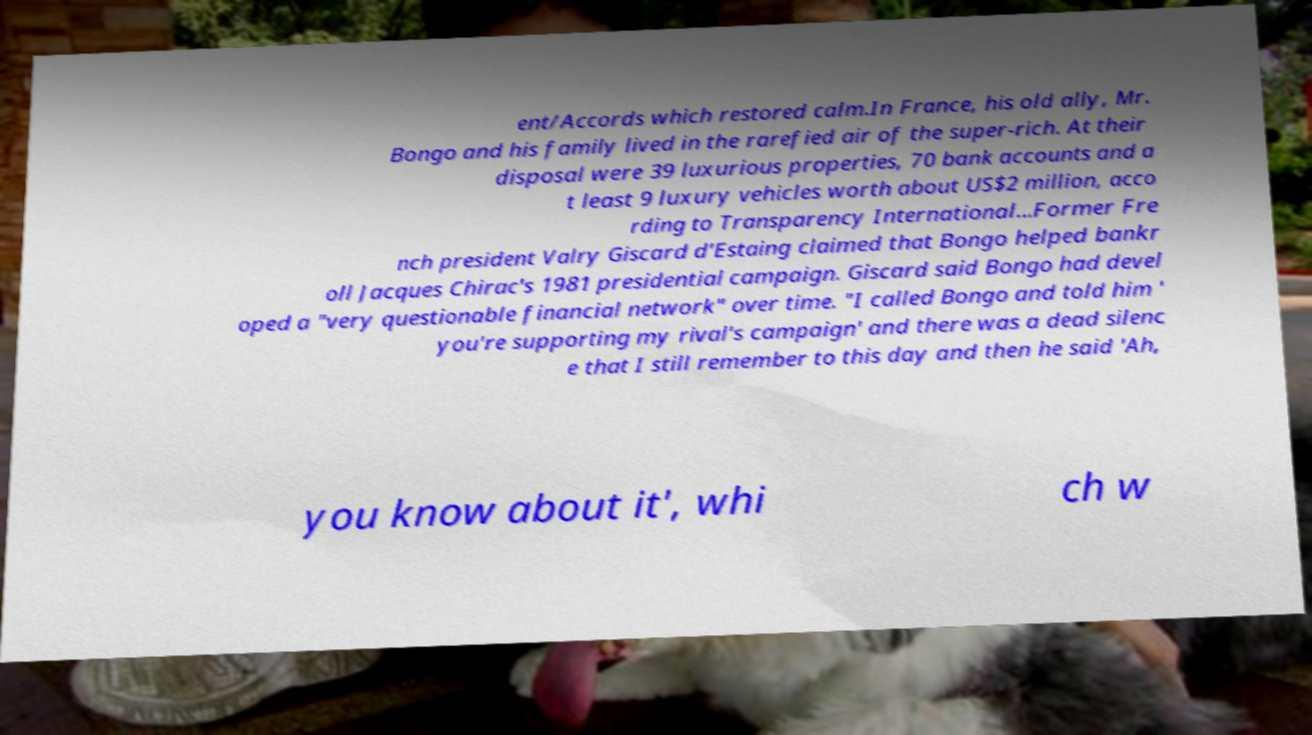There's text embedded in this image that I need extracted. Can you transcribe it verbatim? ent/Accords which restored calm.In France, his old ally, Mr. Bongo and his family lived in the rarefied air of the super-rich. At their disposal were 39 luxurious properties, 70 bank accounts and a t least 9 luxury vehicles worth about US$2 million, acco rding to Transparency International...Former Fre nch president Valry Giscard d'Estaing claimed that Bongo helped bankr oll Jacques Chirac's 1981 presidential campaign. Giscard said Bongo had devel oped a "very questionable financial network" over time. "I called Bongo and told him ' you're supporting my rival's campaign' and there was a dead silenc e that I still remember to this day and then he said 'Ah, you know about it', whi ch w 